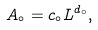Convert formula to latex. <formula><loc_0><loc_0><loc_500><loc_500>A _ { \circ } = c _ { \circ } L ^ { d _ { \circ } } ,</formula> 